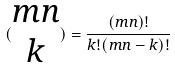<formula> <loc_0><loc_0><loc_500><loc_500>( \begin{matrix} m n \\ k \end{matrix} ) = \frac { ( m n ) ! } { k ! ( m n - k ) ! }</formula> 